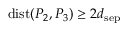<formula> <loc_0><loc_0><loc_500><loc_500>d i s t ( P _ { 2 } , P _ { 3 } ) \geq 2 d _ { s e p }</formula> 